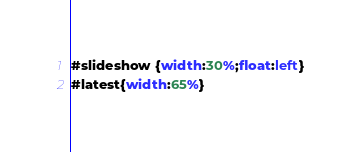<code> <loc_0><loc_0><loc_500><loc_500><_CSS_>#slideshow {width:30%;float:left}
#latest{width:65%}</code> 